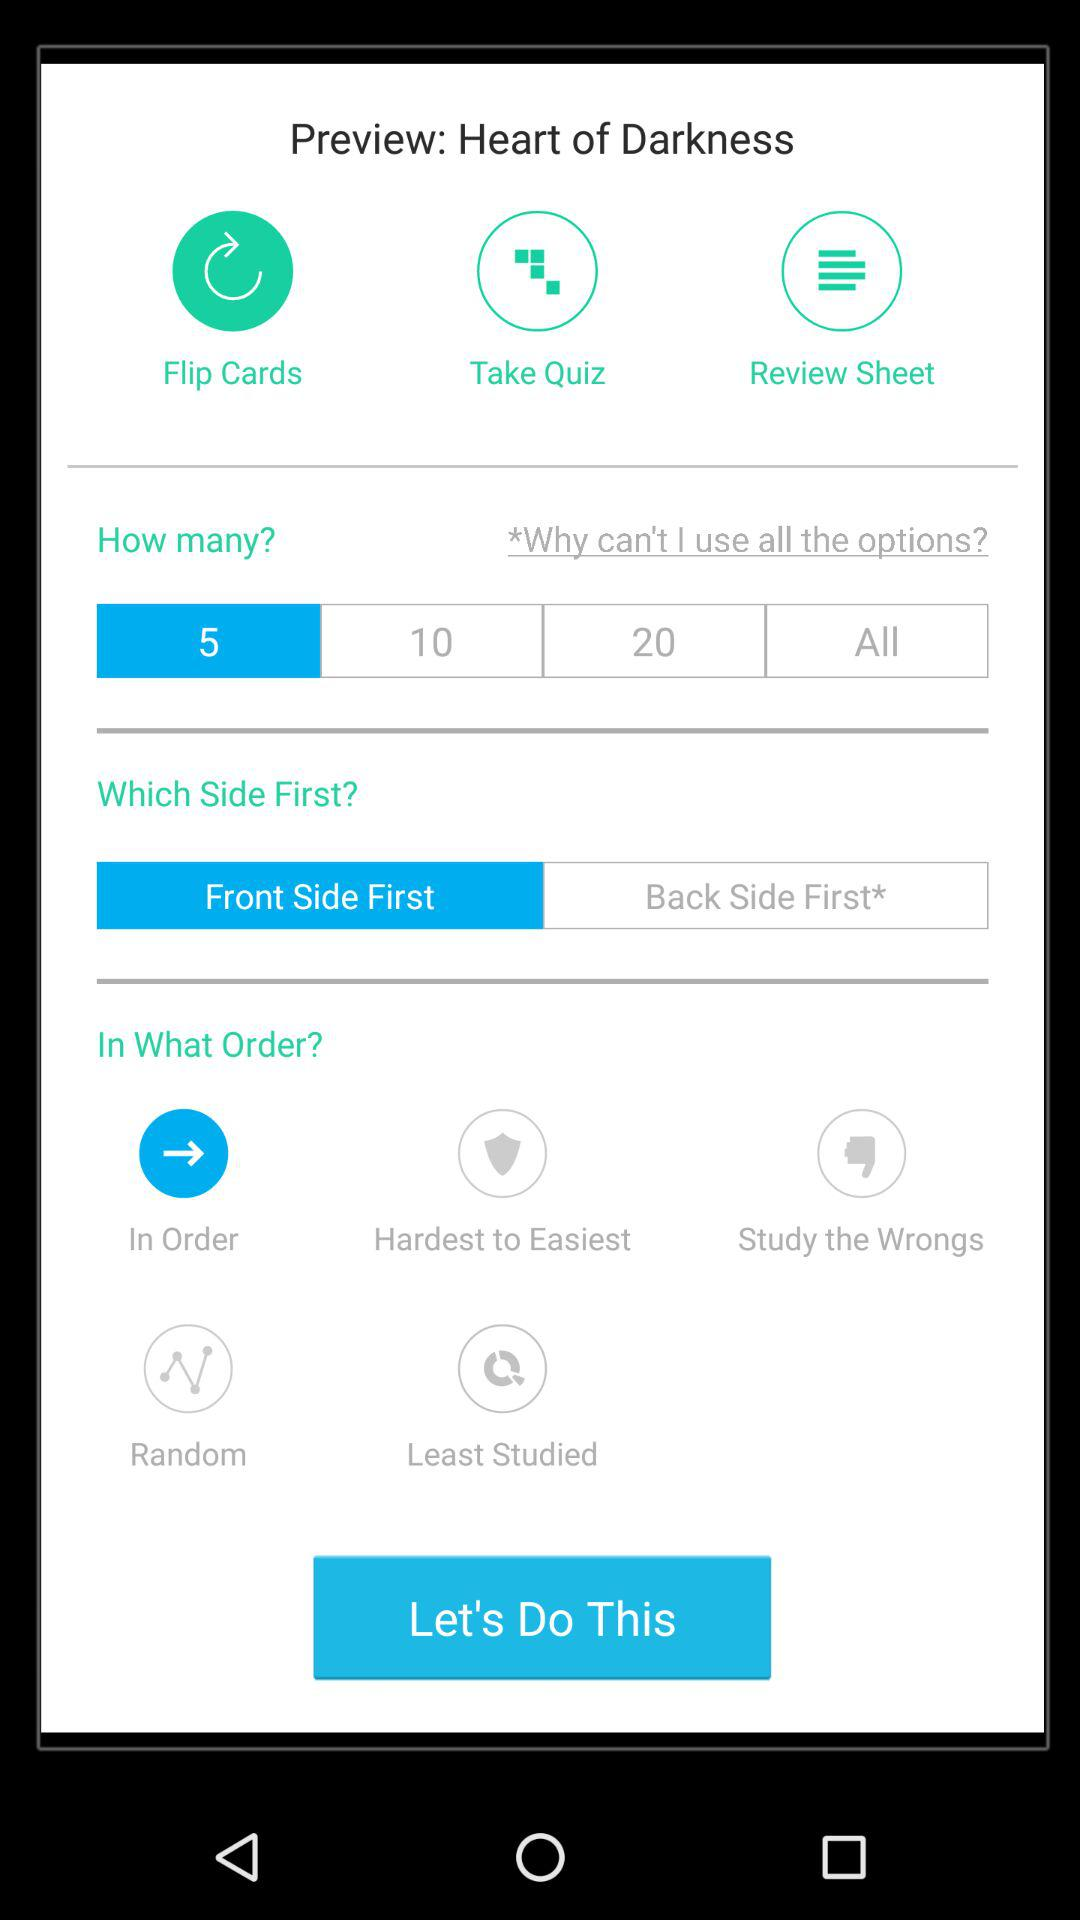How many ways can I choose which side of the card to flip first?
Answer the question using a single word or phrase. 2 